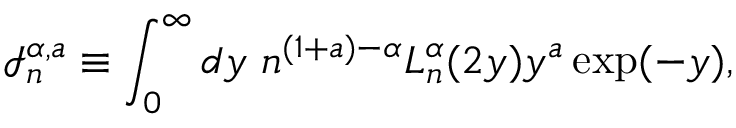Convert formula to latex. <formula><loc_0><loc_0><loc_500><loc_500>\mathcal { I } _ { n } ^ { \alpha , a } \equiv \int _ { 0 } ^ { \infty } d y \ n ^ { ( 1 + a ) - \alpha } L _ { n } ^ { \alpha } ( 2 y ) y ^ { a } \exp ( - y ) ,</formula> 